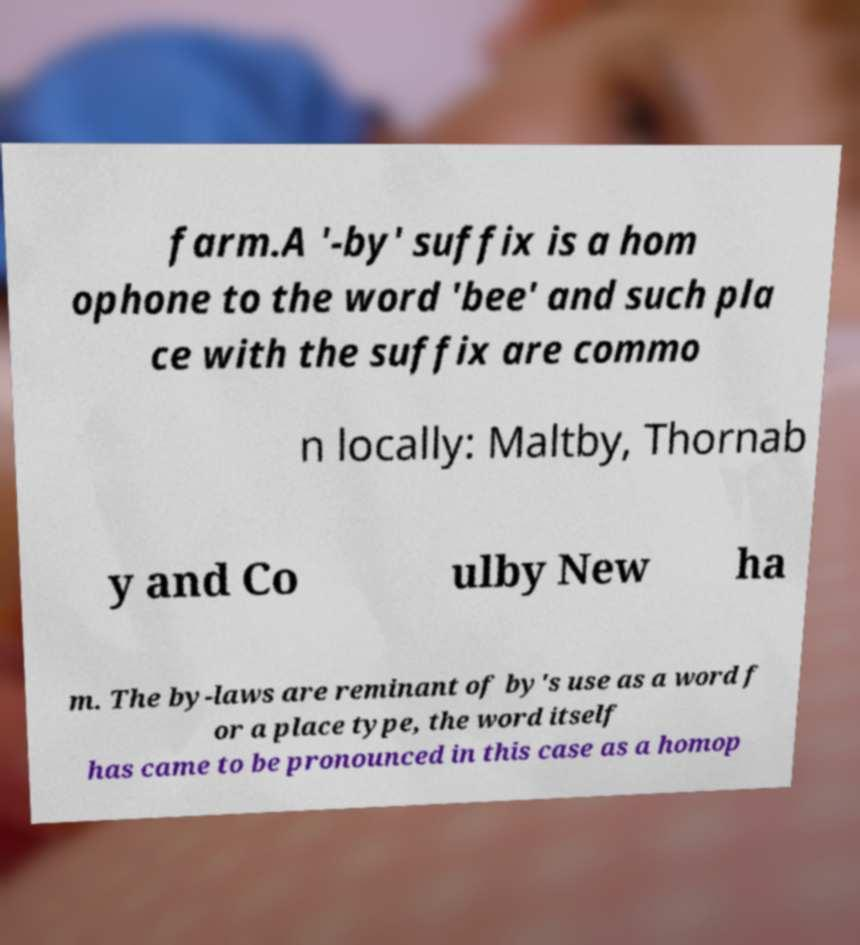Please read and relay the text visible in this image. What does it say? farm.A '-by' suffix is a hom ophone to the word 'bee' and such pla ce with the suffix are commo n locally: Maltby, Thornab y and Co ulby New ha m. The by-laws are reminant of by's use as a word f or a place type, the word itself has came to be pronounced in this case as a homop 